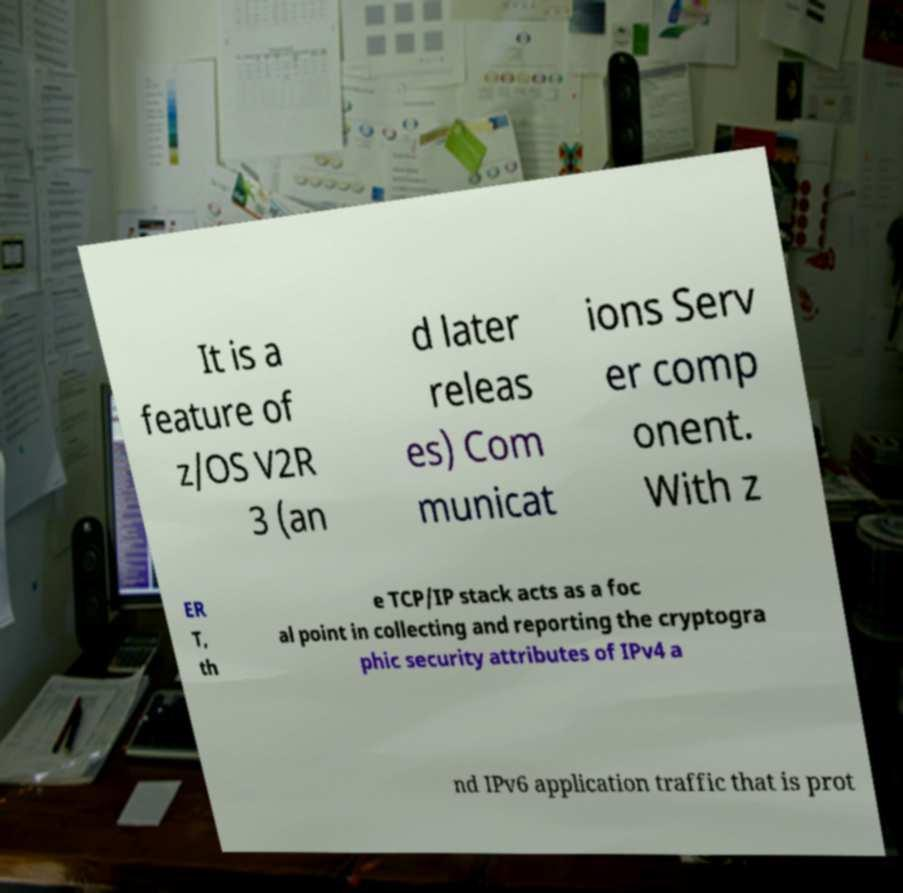Can you accurately transcribe the text from the provided image for me? It is a feature of z/OS V2R 3 (an d later releas es) Com municat ions Serv er comp onent. With z ER T, th e TCP/IP stack acts as a foc al point in collecting and reporting the cryptogra phic security attributes of IPv4 a nd IPv6 application traffic that is prot 